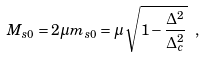Convert formula to latex. <formula><loc_0><loc_0><loc_500><loc_500>M _ { s 0 } = 2 \mu m _ { s 0 } = \mu \, \sqrt { 1 - \frac { \Delta ^ { 2 } } { \Delta _ { c } ^ { 2 } } } \ ,</formula> 